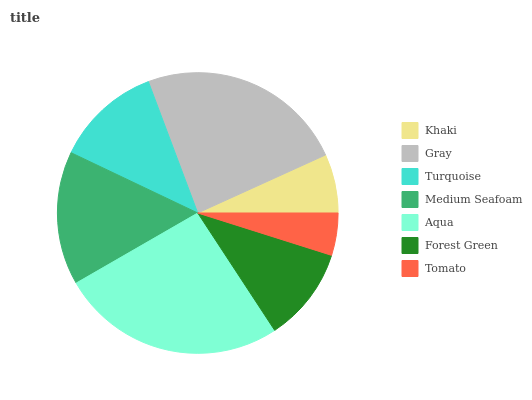Is Tomato the minimum?
Answer yes or no. Yes. Is Aqua the maximum?
Answer yes or no. Yes. Is Gray the minimum?
Answer yes or no. No. Is Gray the maximum?
Answer yes or no. No. Is Gray greater than Khaki?
Answer yes or no. Yes. Is Khaki less than Gray?
Answer yes or no. Yes. Is Khaki greater than Gray?
Answer yes or no. No. Is Gray less than Khaki?
Answer yes or no. No. Is Turquoise the high median?
Answer yes or no. Yes. Is Turquoise the low median?
Answer yes or no. Yes. Is Medium Seafoam the high median?
Answer yes or no. No. Is Khaki the low median?
Answer yes or no. No. 